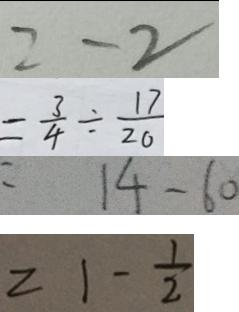Convert formula to latex. <formula><loc_0><loc_0><loc_500><loc_500>= - 2 
 = \frac { 3 } { 4 } \times \frac { 1 7 } { 2 0 } 
 = 1 4 - 6 0 
 = 1 - \frac { 1 } { 2 }</formula> 